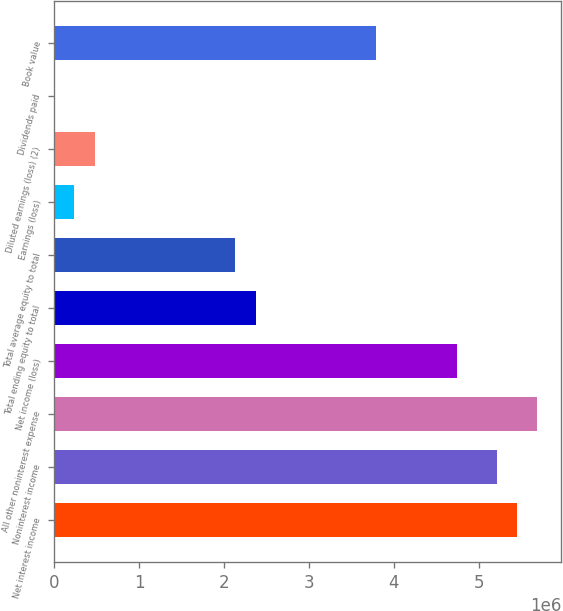Convert chart. <chart><loc_0><loc_0><loc_500><loc_500><bar_chart><fcel>Net interest income<fcel>Noninterest income<fcel>All other noninterest expense<fcel>Net income (loss)<fcel>Total ending equity to total<fcel>Total average equity to total<fcel>Earnings (loss)<fcel>Diluted earnings (loss) (2)<fcel>Dividends paid<fcel>Book value<nl><fcel>5.45159e+06<fcel>5.21457e+06<fcel>5.68862e+06<fcel>4.74052e+06<fcel>2.37026e+06<fcel>2.13323e+06<fcel>237026<fcel>474052<fcel>0.01<fcel>3.79241e+06<nl></chart> 